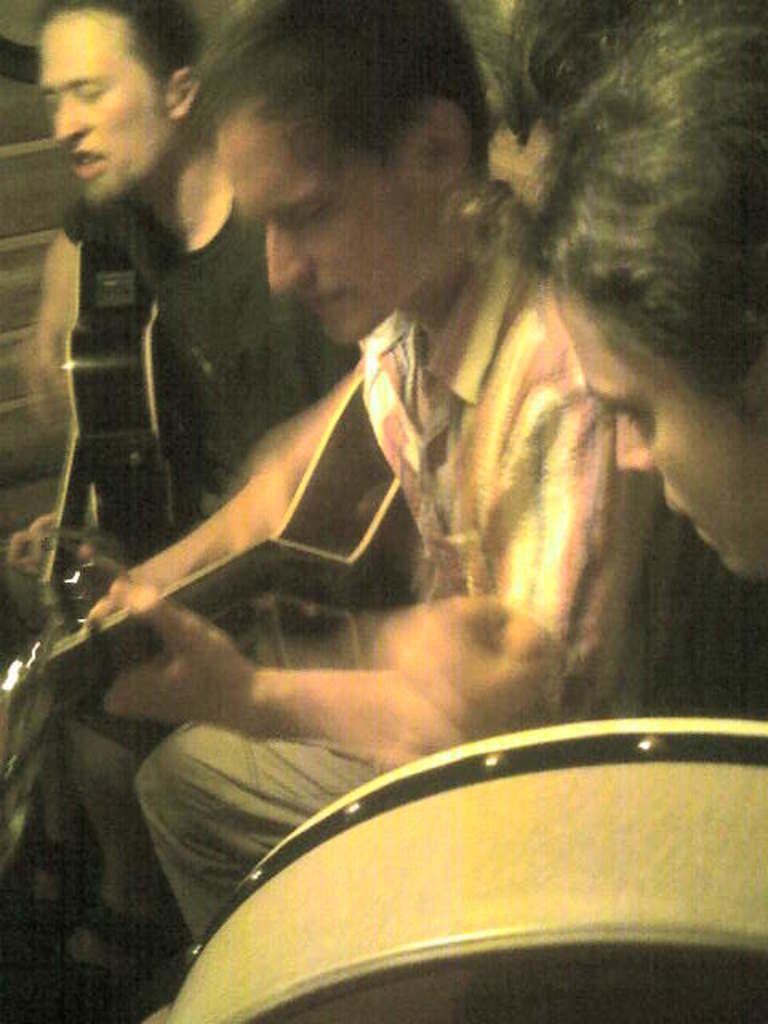Who or what is present in the image? There are people in the image. What are the people doing in the image? The people are playing musical instruments. What is the temperature of the wind in the image? There is no mention of wind in the image, so we cannot determine its temperature. 